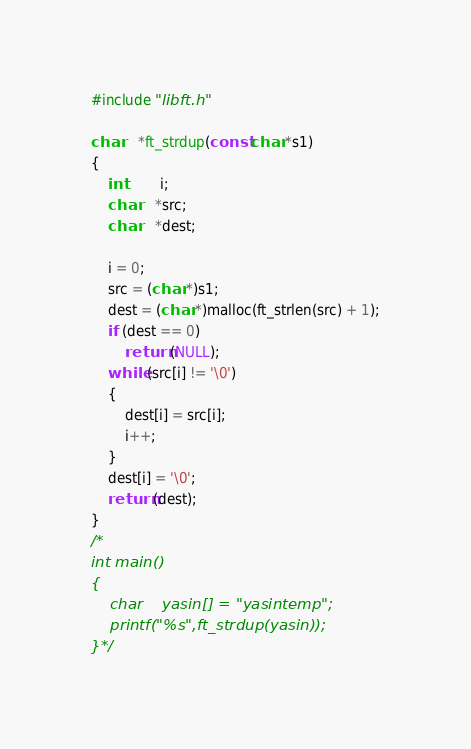<code> <loc_0><loc_0><loc_500><loc_500><_C_>
#include "libft.h"

char	*ft_strdup(const char *s1)
{
	int		i;
	char	*src;
	char	*dest;

	i = 0;
	src = (char *)s1;
	dest = (char *)malloc(ft_strlen(src) + 1);
	if (dest == 0)
		return (NULL);
	while (src[i] != '\0')
	{
		dest[i] = src[i];
		i++;
	}
	dest[i] = '\0';
	return (dest);
}
/*
int	main()
{
	char	yasin[] = "yasintemp";
	printf("%s",ft_strdup(yasin));
}*/
</code> 